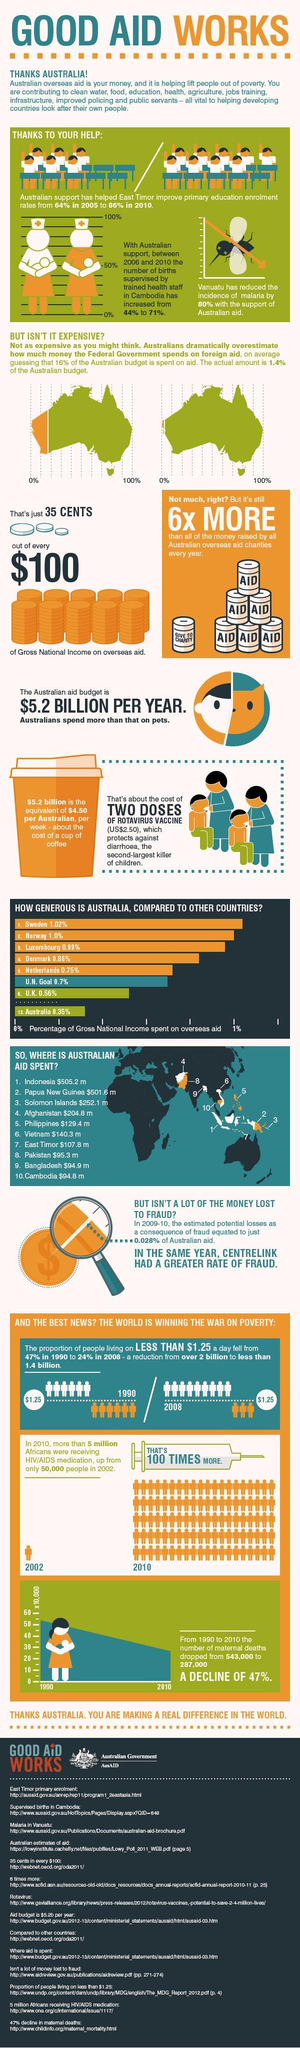What is the percentage of Gross National Income spent on overseas aid by Denmark and the Netherlands, taken together?
Answer the question with a short phrase. 1.61% What is the percentage of Gross National Income spent on overseas aid by Sweden and Norway, taken together? 2.02% What is the percentage increase in the number of births supervised by trained health staff in Cambodia between 2006 and 2010? 27% What is the percentage of Gross National Income spent on overseas aid by Norway and Australia, taken together? 1.35% 